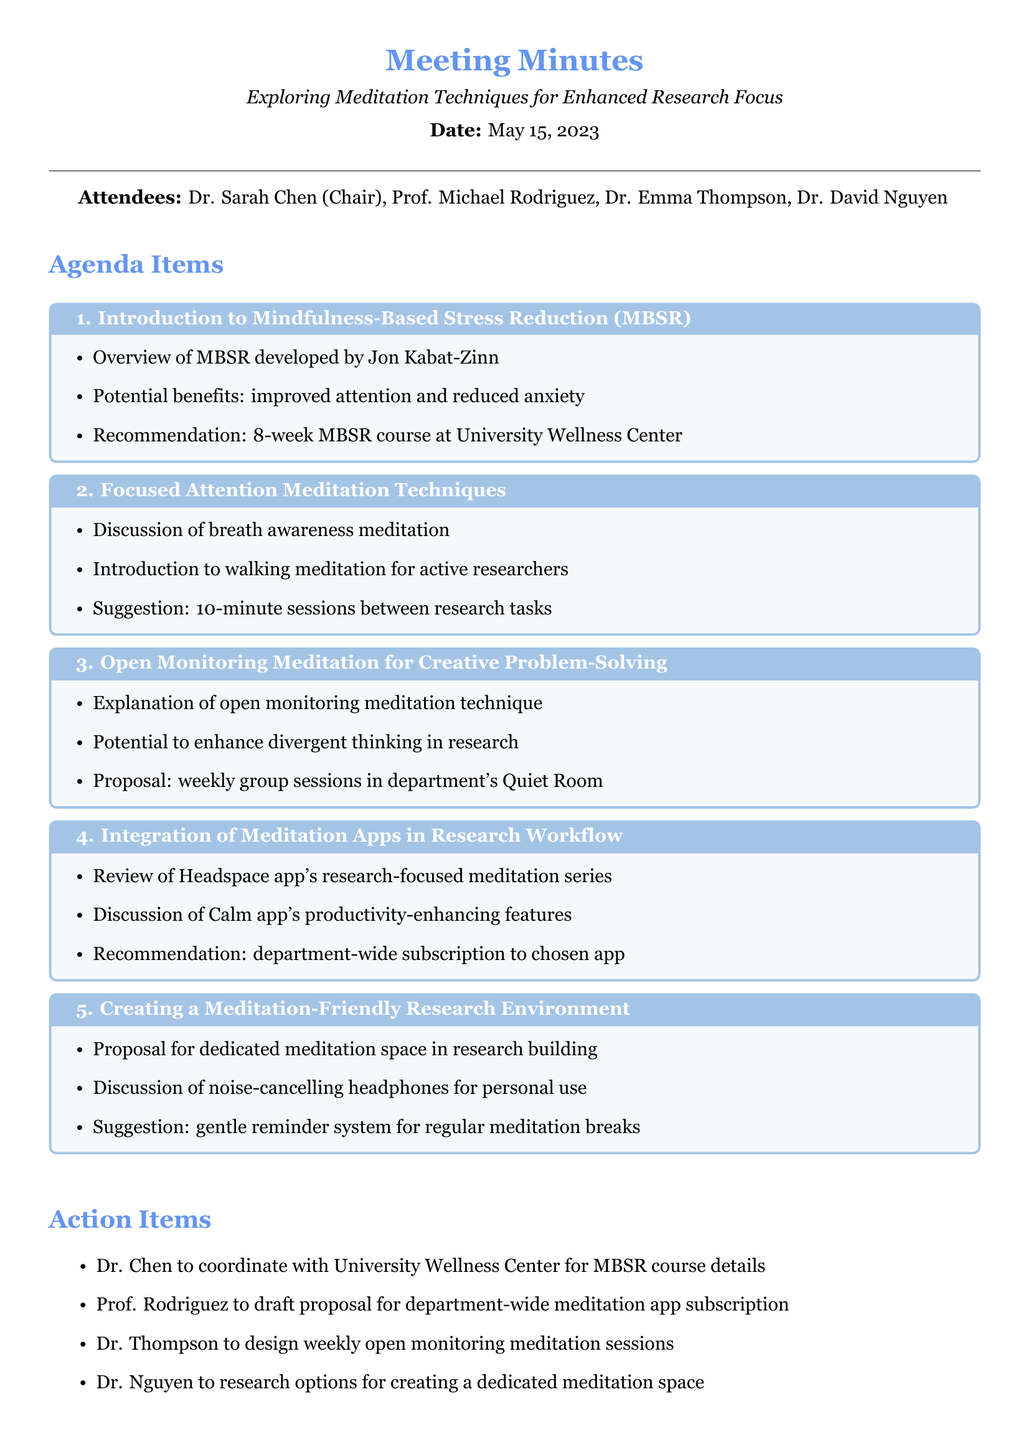What is the meeting title? The meeting title is explicitly stated at the beginning of the document, summarizing the main topic of discussion.
Answer: Exploring Meditation Techniques for Enhanced Research Focus Who chaired the meeting? The minutes list Dr. Sarah Chen as the chairperson of the meeting, indicating her leadership role.
Answer: Dr. Sarah Chen When is the next meeting scheduled? The document specifies the date of the next meeting at the end, providing a future reference.
Answer: June 12, 2023 What meditation technique was introduced for active researchers? The document mentions walking meditation as a suitable technique for those engaged in research activities.
Answer: Walking meditation Which app was reviewed for its research-focused meditation series? The minutes highlight the Headspace app as the one discussed regarding its offerings for research support.
Answer: Headspace Who is responsible for designing weekly open monitoring meditation sessions? The action items section assigns this task to a specific attendee, making it clear who is accountable.
Answer: Dr. Thompson What is one proposed feature for creating a meditation-friendly environment? The document lists a proposal for a dedicated meditation space, suggesting a specific initiative to enhance the research atmosphere.
Answer: Dedicated meditation space What are the potential benefits of MBSR mentioned in the meeting? The attendees discussed the benefits, highlighting improvements in attention and reduction in anxiety as key points.
Answer: Improved attention and reduced anxiety What suggestion was made regarding meditation breaks? One of the suggestions emphasizes the importance of a reminder system for breaks, encouraging regular practice.
Answer: Gentle reminder system for regular meditation breaks 